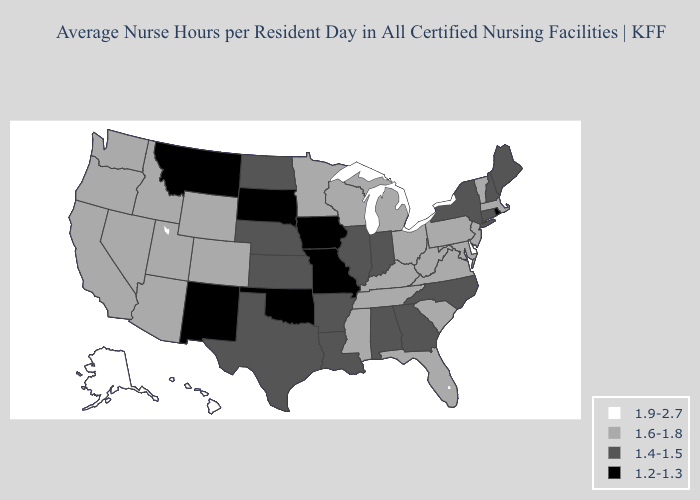What is the value of Montana?
Be succinct. 1.2-1.3. Does Arkansas have the highest value in the South?
Keep it brief. No. Does Alabama have the lowest value in the USA?
Be succinct. No. What is the value of Delaware?
Short answer required. 1.9-2.7. Does Rhode Island have the lowest value in the Northeast?
Write a very short answer. Yes. Which states have the lowest value in the USA?
Be succinct. Iowa, Missouri, Montana, New Mexico, Oklahoma, Rhode Island, South Dakota. Name the states that have a value in the range 1.6-1.8?
Quick response, please. Arizona, California, Colorado, Florida, Idaho, Kentucky, Maryland, Massachusetts, Michigan, Minnesota, Mississippi, Nevada, New Jersey, Ohio, Oregon, Pennsylvania, South Carolina, Tennessee, Utah, Vermont, Virginia, Washington, West Virginia, Wisconsin, Wyoming. Which states have the lowest value in the USA?
Give a very brief answer. Iowa, Missouri, Montana, New Mexico, Oklahoma, Rhode Island, South Dakota. Name the states that have a value in the range 1.2-1.3?
Answer briefly. Iowa, Missouri, Montana, New Mexico, Oklahoma, Rhode Island, South Dakota. What is the value of Wisconsin?
Give a very brief answer. 1.6-1.8. Does Delaware have the highest value in the USA?
Short answer required. Yes. Is the legend a continuous bar?
Answer briefly. No. Which states have the lowest value in the MidWest?
Quick response, please. Iowa, Missouri, South Dakota. Name the states that have a value in the range 1.9-2.7?
Answer briefly. Alaska, Delaware, Hawaii. Does Alaska have a lower value than Kansas?
Keep it brief. No. 